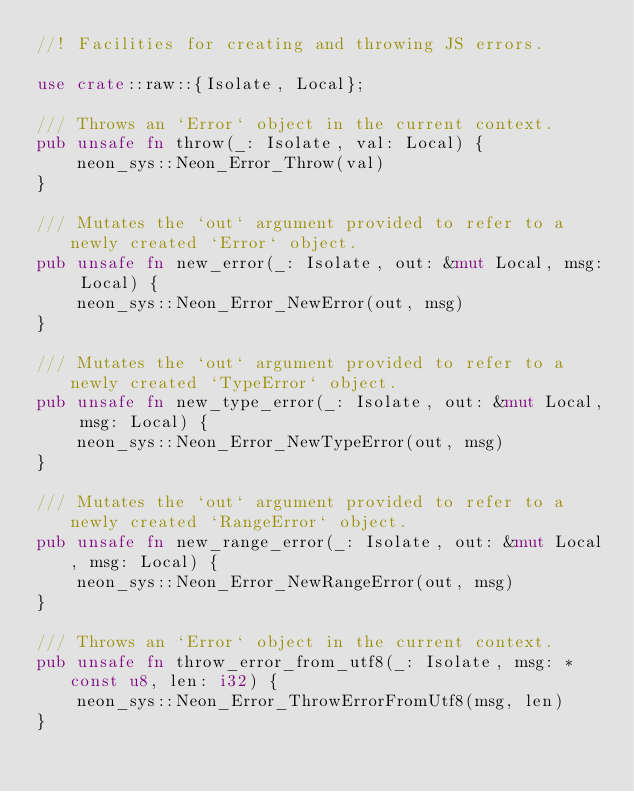<code> <loc_0><loc_0><loc_500><loc_500><_Rust_>//! Facilities for creating and throwing JS errors.

use crate::raw::{Isolate, Local};

/// Throws an `Error` object in the current context.
pub unsafe fn throw(_: Isolate, val: Local) {
    neon_sys::Neon_Error_Throw(val)
}

/// Mutates the `out` argument provided to refer to a newly created `Error` object.
pub unsafe fn new_error(_: Isolate, out: &mut Local, msg: Local) {
    neon_sys::Neon_Error_NewError(out, msg)
}

/// Mutates the `out` argument provided to refer to a newly created `TypeError` object.
pub unsafe fn new_type_error(_: Isolate, out: &mut Local, msg: Local) {
    neon_sys::Neon_Error_NewTypeError(out, msg)
}

/// Mutates the `out` argument provided to refer to a newly created `RangeError` object.
pub unsafe fn new_range_error(_: Isolate, out: &mut Local, msg: Local) {
    neon_sys::Neon_Error_NewRangeError(out, msg)
}

/// Throws an `Error` object in the current context.
pub unsafe fn throw_error_from_utf8(_: Isolate, msg: *const u8, len: i32) {
    neon_sys::Neon_Error_ThrowErrorFromUtf8(msg, len)
}
</code> 